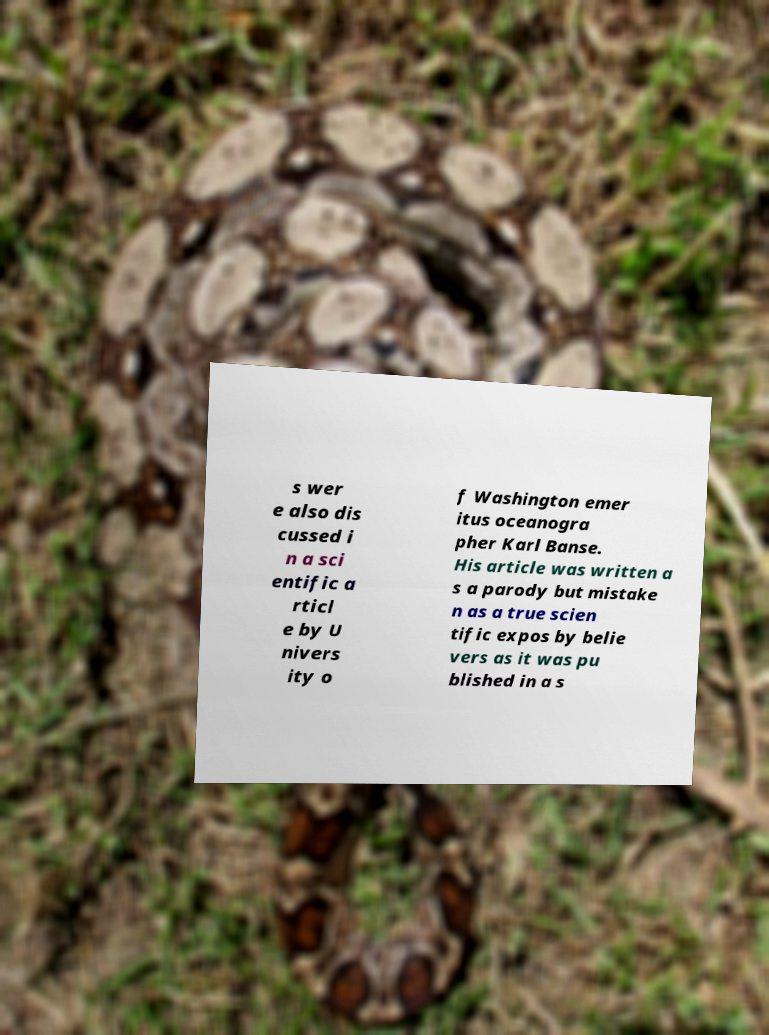Can you read and provide the text displayed in the image?This photo seems to have some interesting text. Can you extract and type it out for me? s wer e also dis cussed i n a sci entific a rticl e by U nivers ity o f Washington emer itus oceanogra pher Karl Banse. His article was written a s a parody but mistake n as a true scien tific expos by belie vers as it was pu blished in a s 